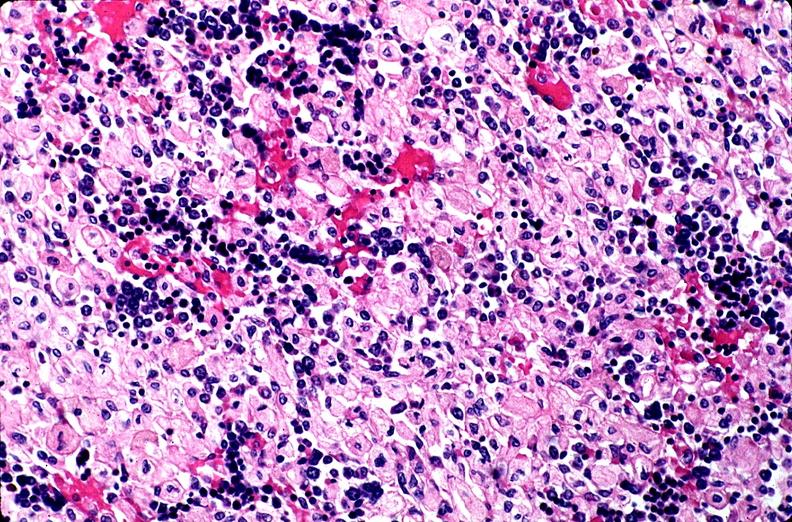does this image show gaucher disease?
Answer the question using a single word or phrase. Yes 